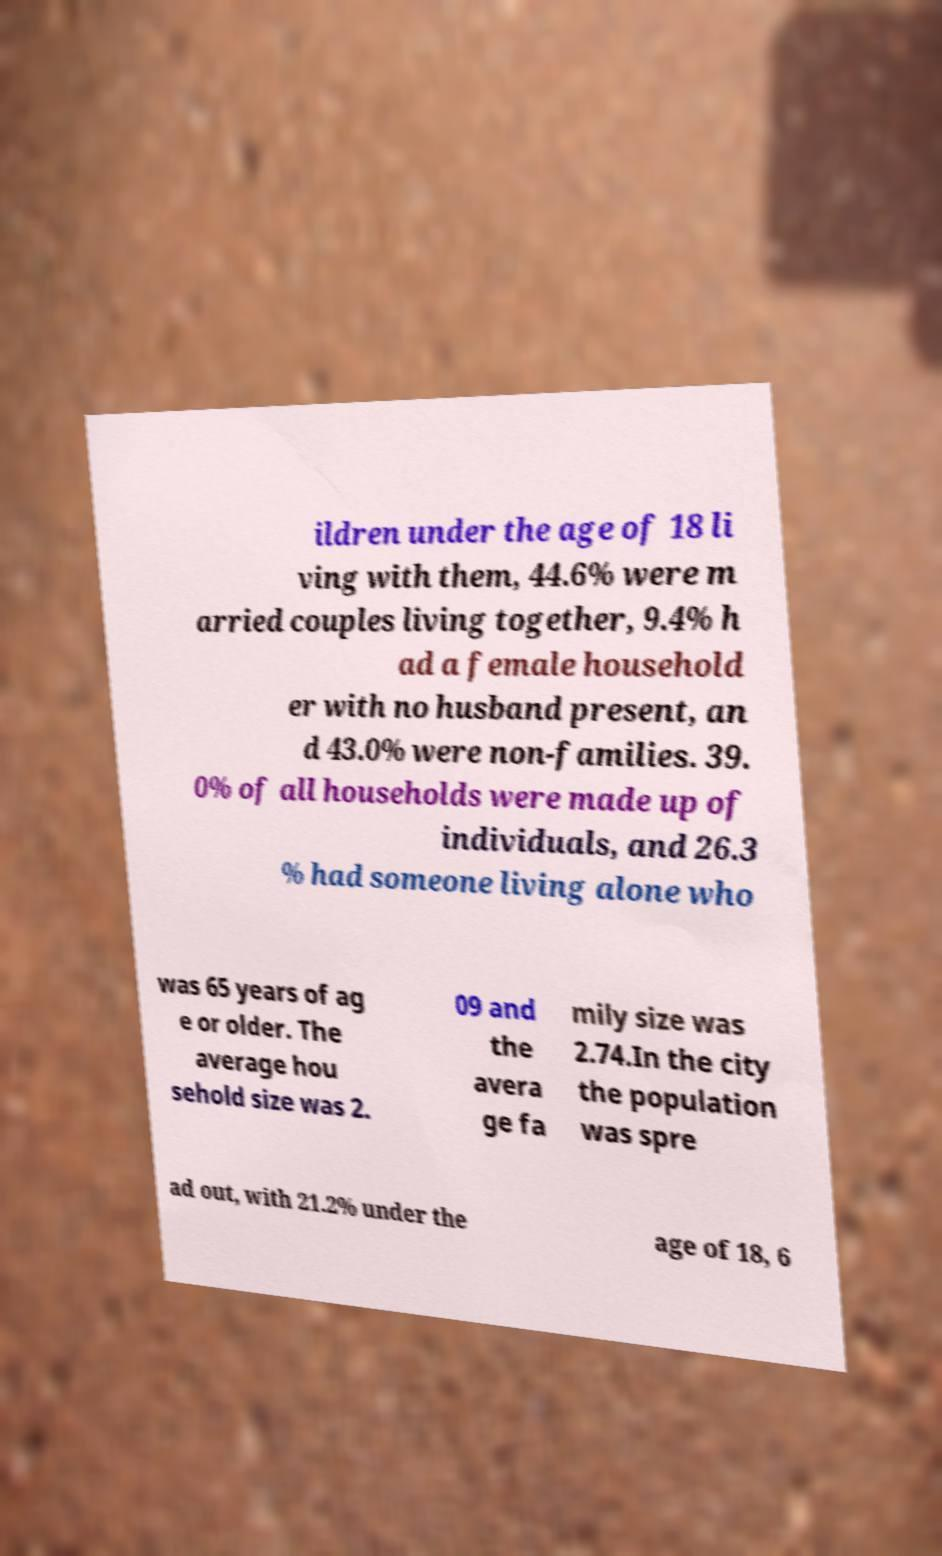Could you assist in decoding the text presented in this image and type it out clearly? ildren under the age of 18 li ving with them, 44.6% were m arried couples living together, 9.4% h ad a female household er with no husband present, an d 43.0% were non-families. 39. 0% of all households were made up of individuals, and 26.3 % had someone living alone who was 65 years of ag e or older. The average hou sehold size was 2. 09 and the avera ge fa mily size was 2.74.In the city the population was spre ad out, with 21.2% under the age of 18, 6 